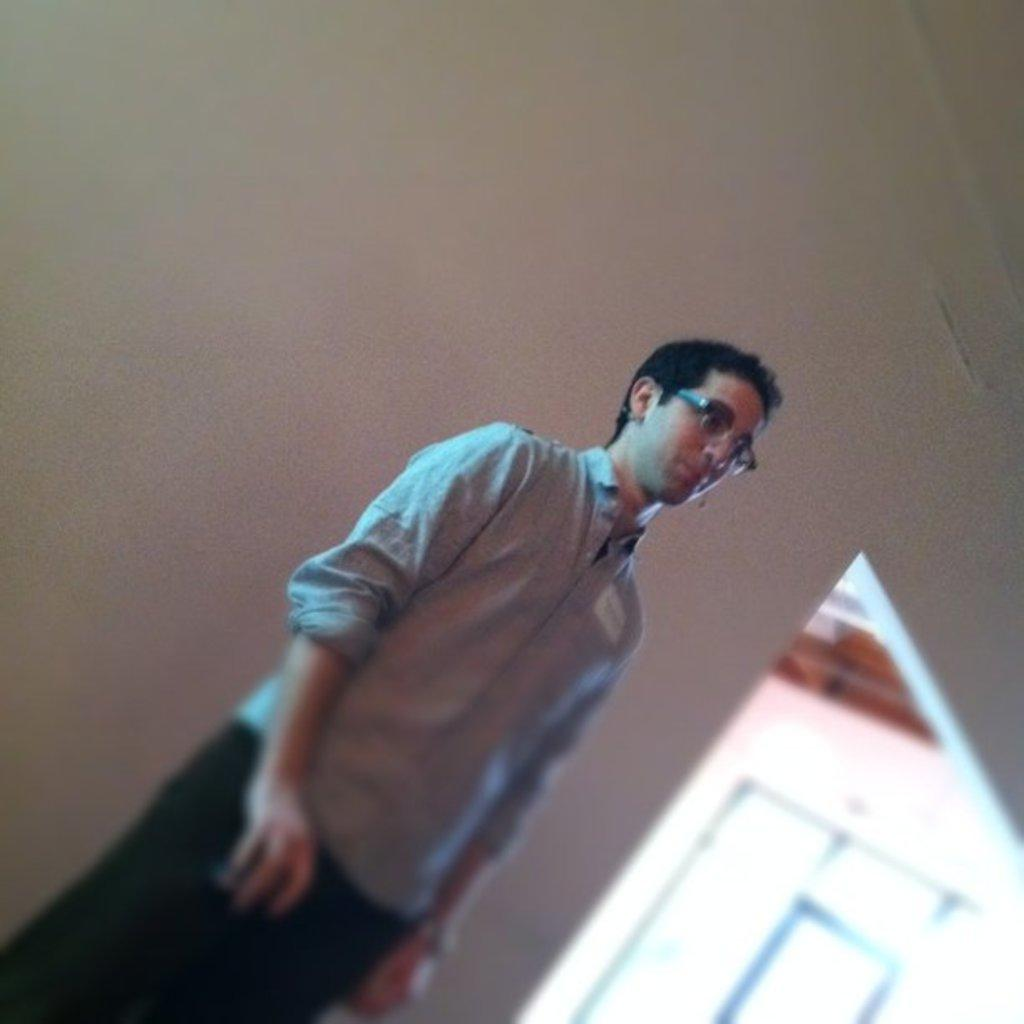Who or what is present in the image? There is a person in the image. What is the person wearing on their upper body? The person is wearing a shirt. What accessory is the person wearing on their face? The person is wearing spectacles. Where is the person located in relation to the wall? The person is standing near a wall. What type of yam is being cooked on the moon in the image? There is no yam or moon present in the image; it features a person wearing a shirt and spectacles while standing near a wall. 